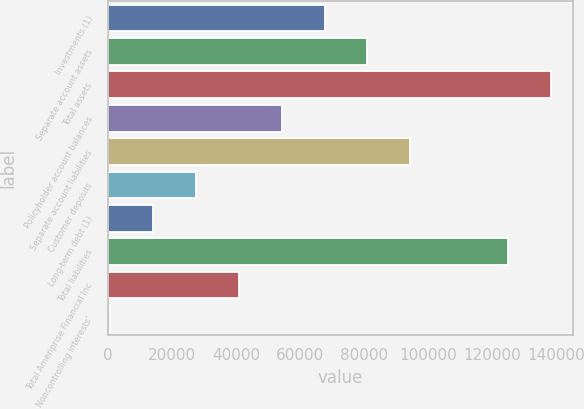<chart> <loc_0><loc_0><loc_500><loc_500><bar_chart><fcel>Investments (1)<fcel>Separate account assets<fcel>Total assets<fcel>Policyholder account balances<fcel>Separate account liabilities<fcel>Customer deposits<fcel>Long-term debt (1)<fcel>Total liabilities<fcel>Total Ameriprise Financial Inc<fcel>Noncontrolling interests'<nl><fcel>67674.5<fcel>81085.4<fcel>138428<fcel>54263.6<fcel>94496.3<fcel>27441.8<fcel>14030.9<fcel>125017<fcel>40852.7<fcel>620<nl></chart> 